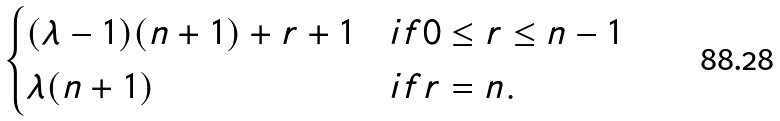Convert formula to latex. <formula><loc_0><loc_0><loc_500><loc_500>\begin{cases} ( \lambda - 1 ) ( n + 1 ) + r + 1 & i f 0 \leq r \leq n - 1 \\ \lambda ( n + 1 ) & i f r = n . \\ \end{cases}</formula> 